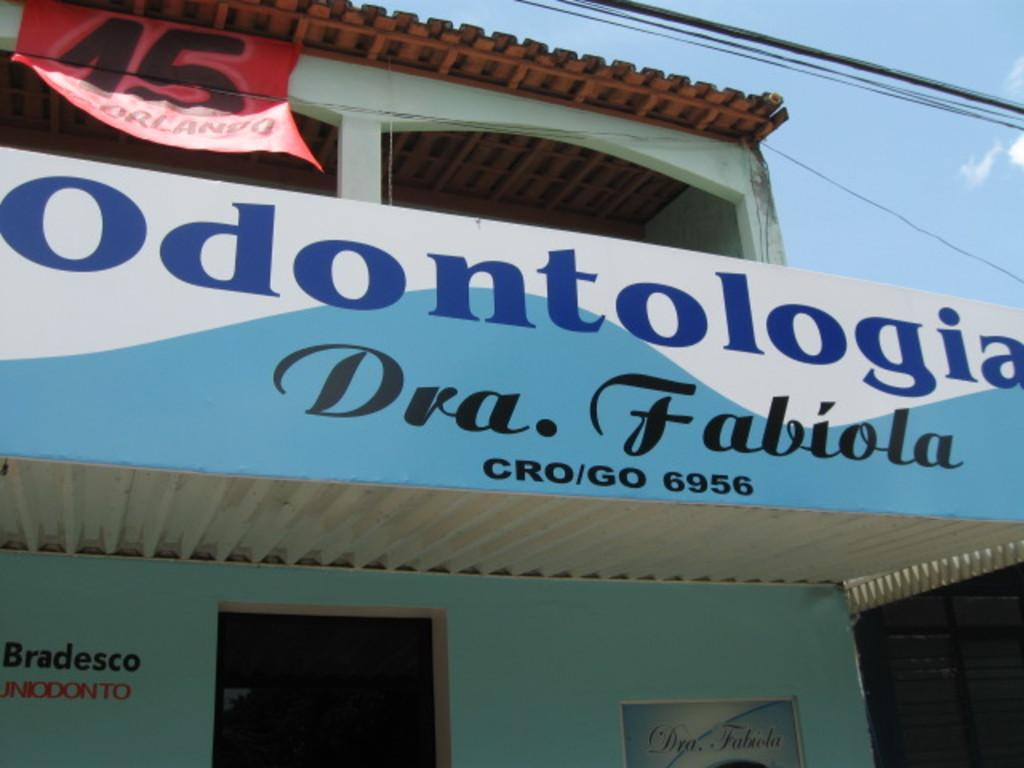What type of structure is present in the image? There is a building in the image. What can be seen on the building in the image? Boards are visible on the building in the image. Where is the entrance to the building located? There is a door at the bottom of the building. What is visible in the background of the image? The sky and wires are visible in the background of the image. What type of soda is being served in the image? There is no soda present in the image. Can you describe the ant's behavior in the image? There are no ants present in the image. 